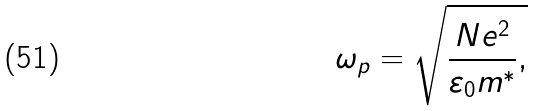<formula> <loc_0><loc_0><loc_500><loc_500>\omega _ { p } = \sqrt { \frac { N e ^ { 2 } } { \varepsilon _ { 0 } m ^ { \ast } } , }</formula> 